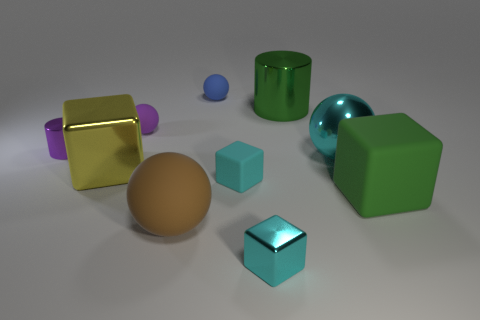The large object that is to the right of the green cylinder and in front of the yellow metallic object has what shape?
Ensure brevity in your answer.  Cube. What size is the yellow thing that is made of the same material as the big cyan thing?
Ensure brevity in your answer.  Large. Are there fewer tiny purple shiny things than large gray metal objects?
Offer a terse response. No. What is the material of the cyan block that is behind the small shiny thing that is to the right of the rubber ball that is in front of the metallic sphere?
Provide a succinct answer. Rubber. Is the big object that is behind the purple ball made of the same material as the large green thing in front of the big cyan metallic thing?
Provide a short and direct response. No. There is a matte thing that is behind the large green matte cube and in front of the big yellow object; what is its size?
Offer a terse response. Small. What is the material of the cube that is the same size as the yellow thing?
Ensure brevity in your answer.  Rubber. How many small purple cylinders are on the right side of the small blue rubber sphere behind the green cube that is on the right side of the large yellow shiny thing?
Provide a succinct answer. 0. Do the tiny rubber thing that is behind the tiny purple matte sphere and the large rubber thing that is right of the shiny ball have the same color?
Ensure brevity in your answer.  No. The big object that is both right of the tiny blue thing and in front of the yellow cube is what color?
Your answer should be very brief. Green. 